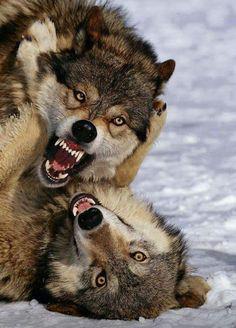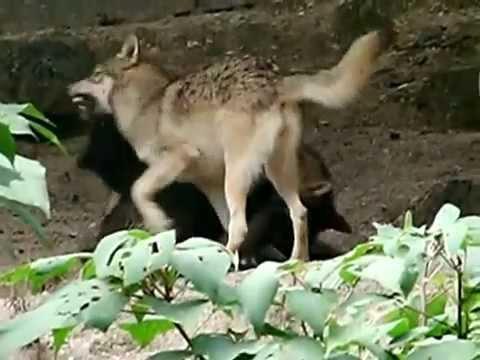The first image is the image on the left, the second image is the image on the right. Analyze the images presented: Is the assertion "All of the wolves are on the snow." valid? Answer yes or no. No. 